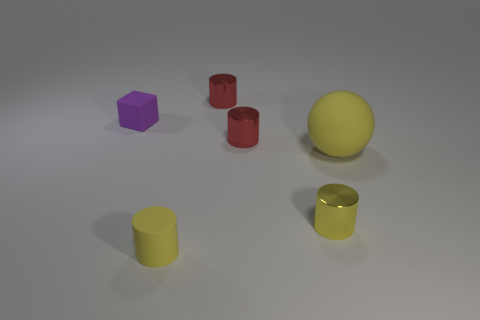Subtract all tiny matte cylinders. How many cylinders are left? 3 Subtract all red cylinders. How many cylinders are left? 2 Add 1 cylinders. How many objects exist? 7 Subtract all cyan cubes. How many yellow cylinders are left? 2 Subtract all cylinders. How many objects are left? 2 Subtract 2 cylinders. How many cylinders are left? 2 Subtract all blue balls. Subtract all brown blocks. How many balls are left? 1 Subtract all tiny red cylinders. Subtract all yellow objects. How many objects are left? 1 Add 3 tiny purple matte blocks. How many tiny purple matte blocks are left? 4 Add 2 small brown metallic balls. How many small brown metallic balls exist? 2 